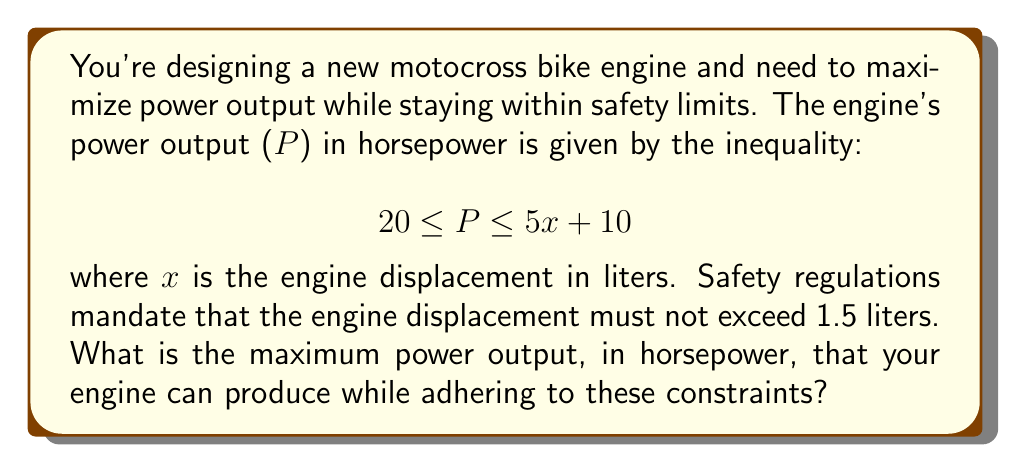Provide a solution to this math problem. To solve this problem, we need to follow these steps:

1. Identify the constraints:
   - Power output (P) is bounded by: $20 \leq P \leq 5x + 10$
   - Engine displacement (x) is limited to: $x \leq 1.5$ liters

2. To find the maximum power output, we need to use the upper bound of the inequality:
   $P = 5x + 10$

3. Since we want to maximize P, we should use the maximum allowed value for x:
   $x = 1.5$ liters

4. Substitute x = 1.5 into the power equation:
   $P = 5(1.5) + 10$
   $P = 7.5 + 10$
   $P = 17.5$

5. Therefore, the maximum power output is 17.5 horsepower.

6. Verify that this satisfies the lower bound of the original inequality:
   $20 \leq 17.5 \leq 5(1.5) + 10$
   $20 \leq 17.5 \leq 17.5$

   The upper bound is satisfied, but the lower bound is not. This means we need to use the lower bound as our maximum power output.

7. The maximum power output that satisfies all constraints is 20 horsepower.
Answer: 20 horsepower 